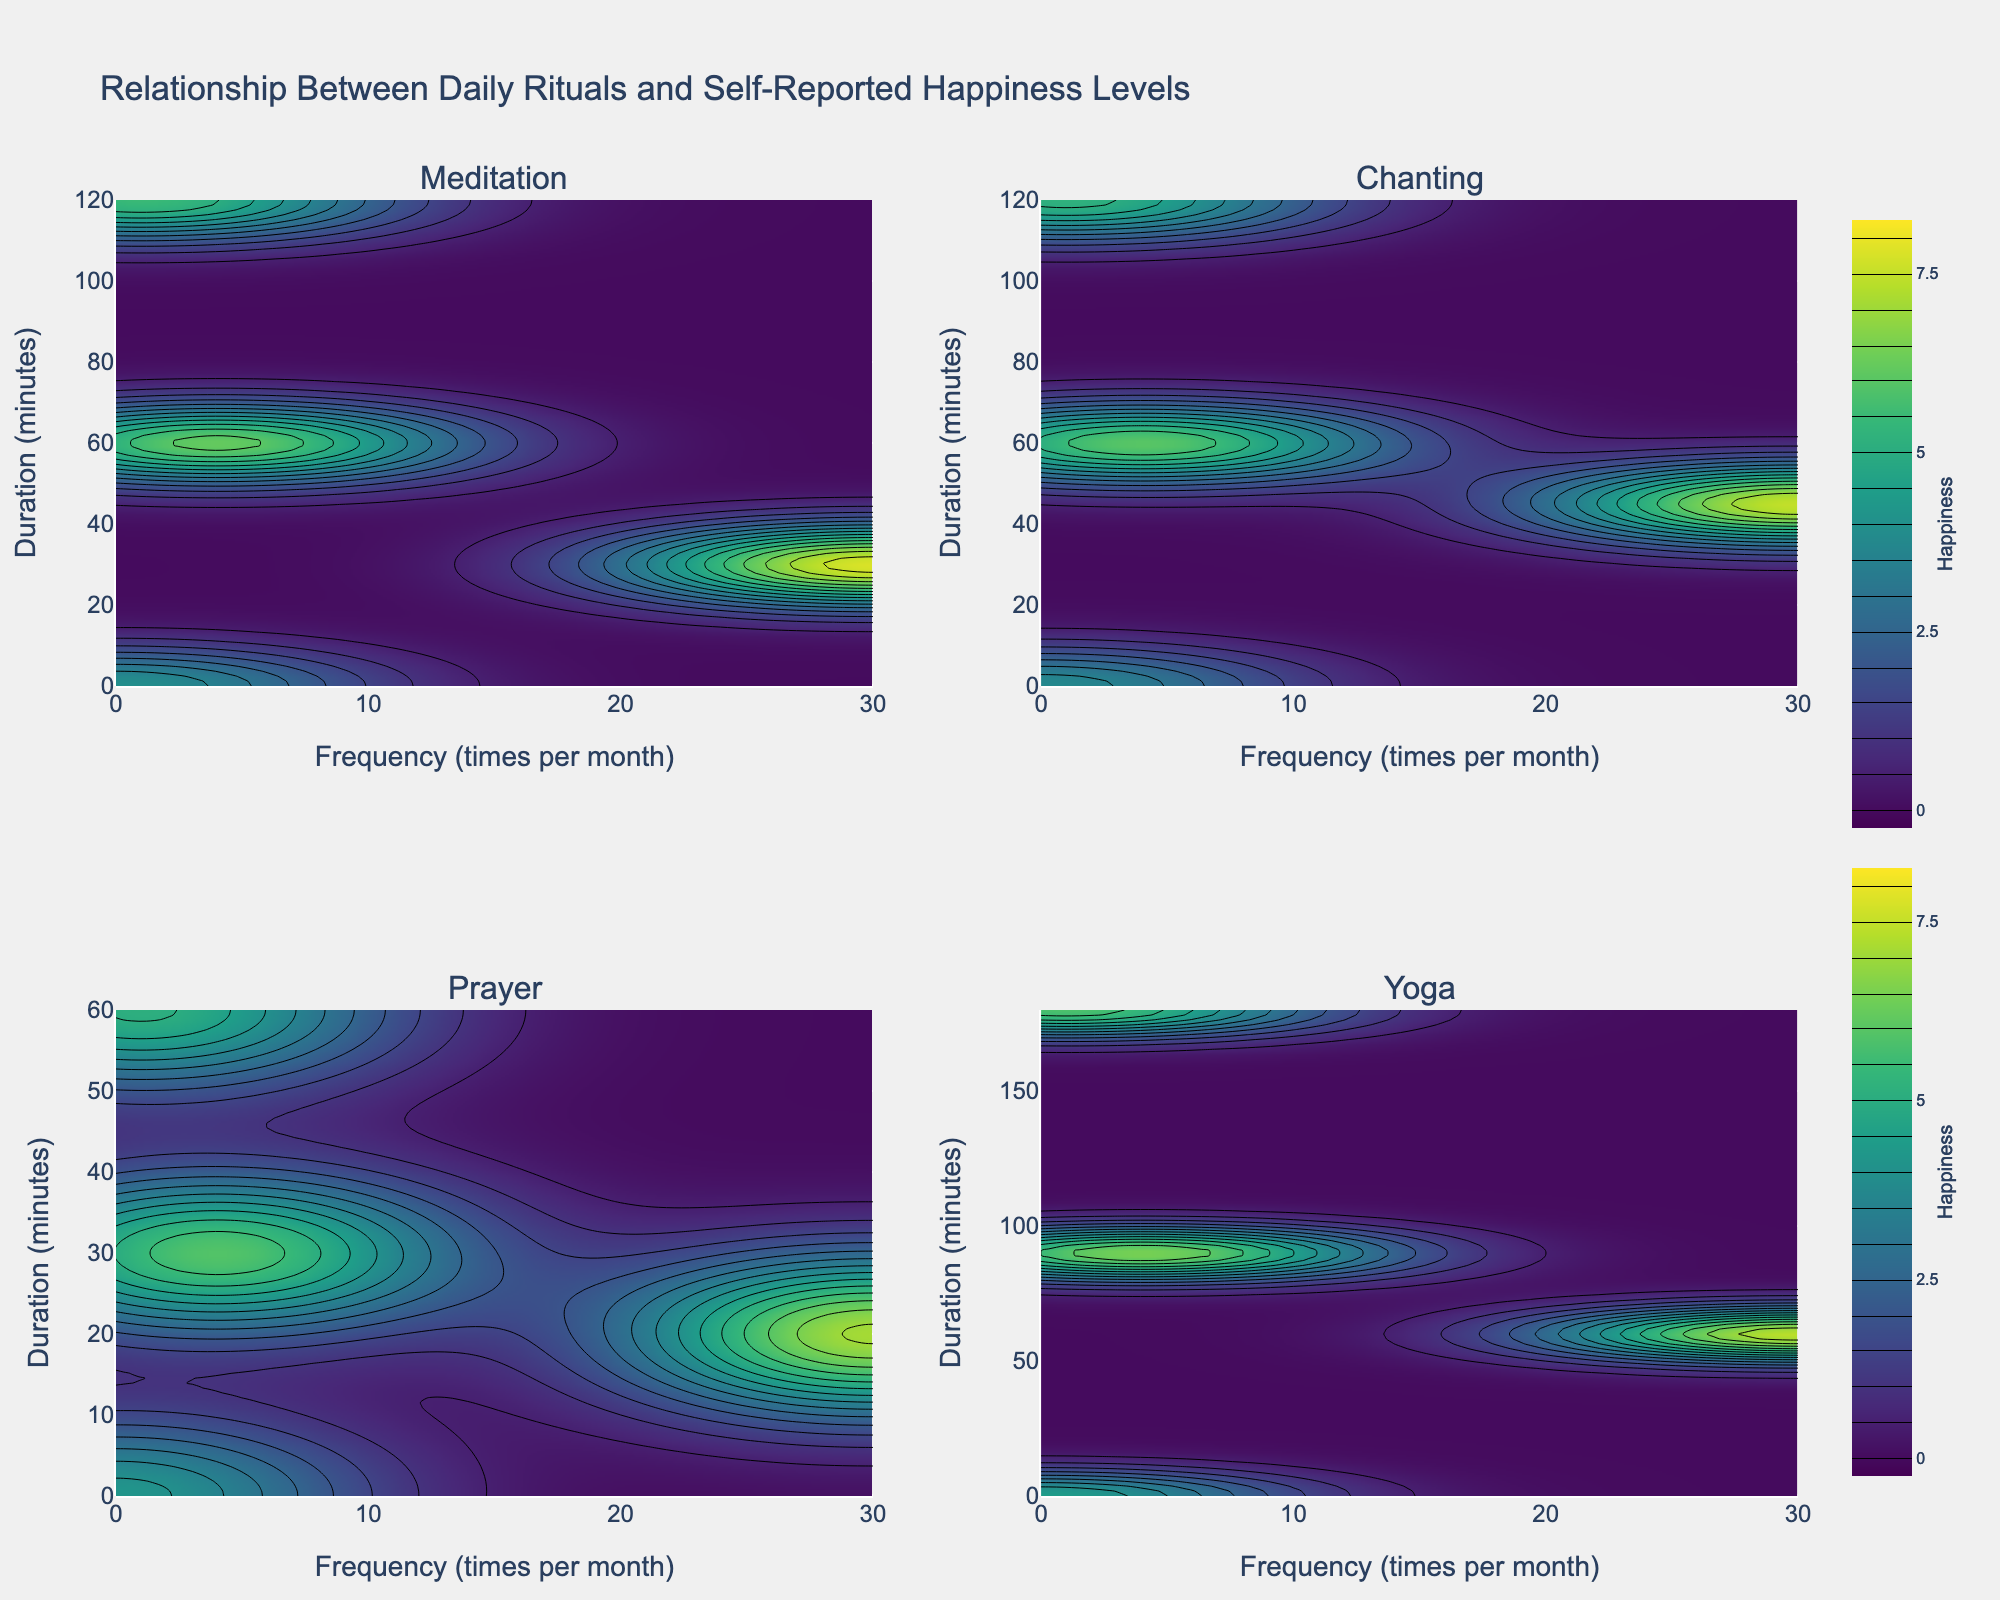What is the title of the figure? The title is typically the text displayed at the top of the figure, setting the context for the viewer. The title of this figure is given in the layout settings.
Answer: Relationship Between Daily Rituals and Self-Reported Happiness Levels What are the axis labels for the subplots? The labels for the axes provide information on what each axis represents. According to the code, the x-axis represents "Frequency (times per month)" and the y-axis represents "Duration (minutes)".
Answer: Frequency (times per month), Duration (minutes) Which ritual shows the highest Self-Reported Happiness for daily practice? The contour plots visually represent happiness levels with different colors. The daily practice can be identified at the highest x-values. The peak color intensity, representing the highest happiness, should be identified. Inspecting the subplot titles and colors helps identify this.
Answer: Meditation For which ritual and frequency does a duration of 45 minutes correspond to a happiness level of approximately 7.5? To determine this, you identify the subplot for each ritual, look at the color/intensity representing a happiness level of 7.5, and then check the corresponding x (frequency) and y (duration) values.
Answer: Chanting, Daily Which ritual shows the least variance in Self-Reported Happiness levels across different durations and frequencies? To find this, compare the color spread of the contour plots across different rituals. A plot with less variation in color intensity indicates lower variance in happiness levels.
Answer: Prayer Compare the self-reported happiness for Daily Meditation and Weekly Meditation. Which is higher? By looking at the "Meditation" subplot, compare the color representation for the x-values corresponding to "Daily" and "Weekly" frequency. The daily routine should show a higher intensity color based on the happiness scores.
Answer: Daily Meditation Which ritual has the lowest Self-Reported Happiness level when practiced monthly? Look at each subplot and identify the color corresponding to monthly practice (x-value baseline for Monthly). The subplot showing the lowest color intensity at that position represents the lowest happiness level.
Answer: Chanting What is the contour color scheme used in the plots? The contour color scheme is specified in the code as 'Viridis'. This provides a range of colors from blue to green to yellow, indicating different happiness levels.
Answer: Viridis Which ritual seems to provide the most consistent happiness levels when practiced weekly compared to other frequencies and durations? Identify the "Weekly" frequency on the x-axis and observe how consistent the colors are across various durations (y-axis). The ritual with the least color variation suggests consistent happiness levels.
Answer: Yoga Compare the Self-Reported Happiness levels for Monthly and Never frequencies for Yoga practice. Which is higher? In the 'Yoga' subplot, compare the color intensities at the monthly (x>0) and never (x=0) frequencies along the y-axis for varying durations. Monthly should show higher intensity.
Answer: Monthly 